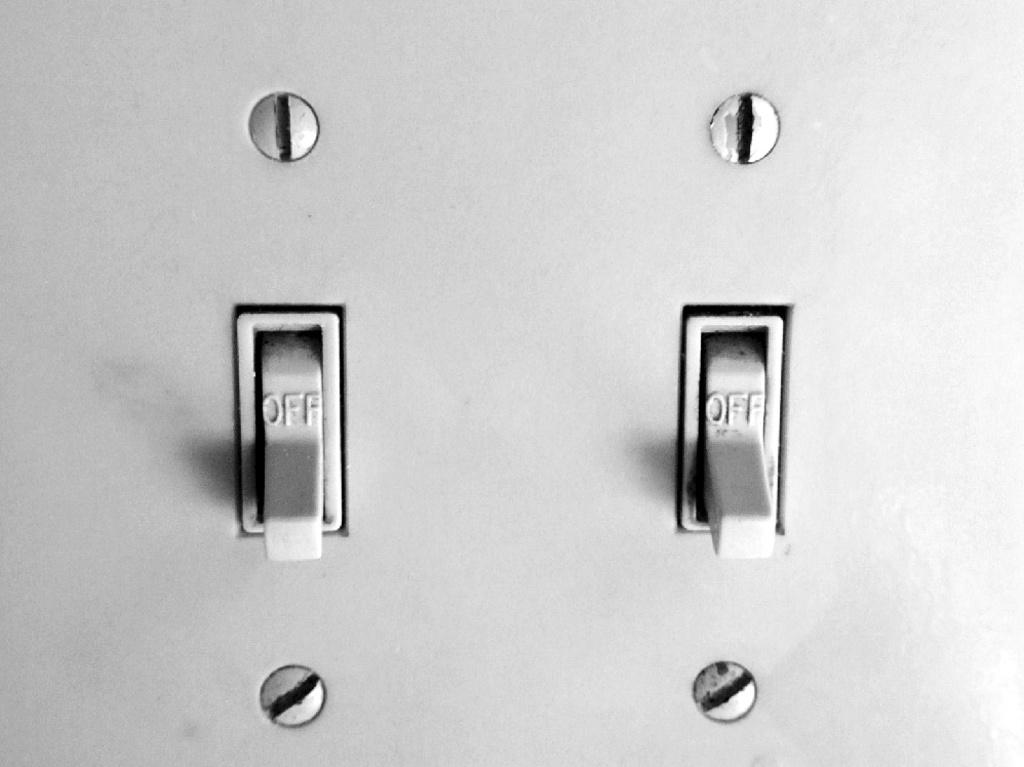<image>
Provide a brief description of the given image. A double switch light sits against the wall with both switches in the off position 